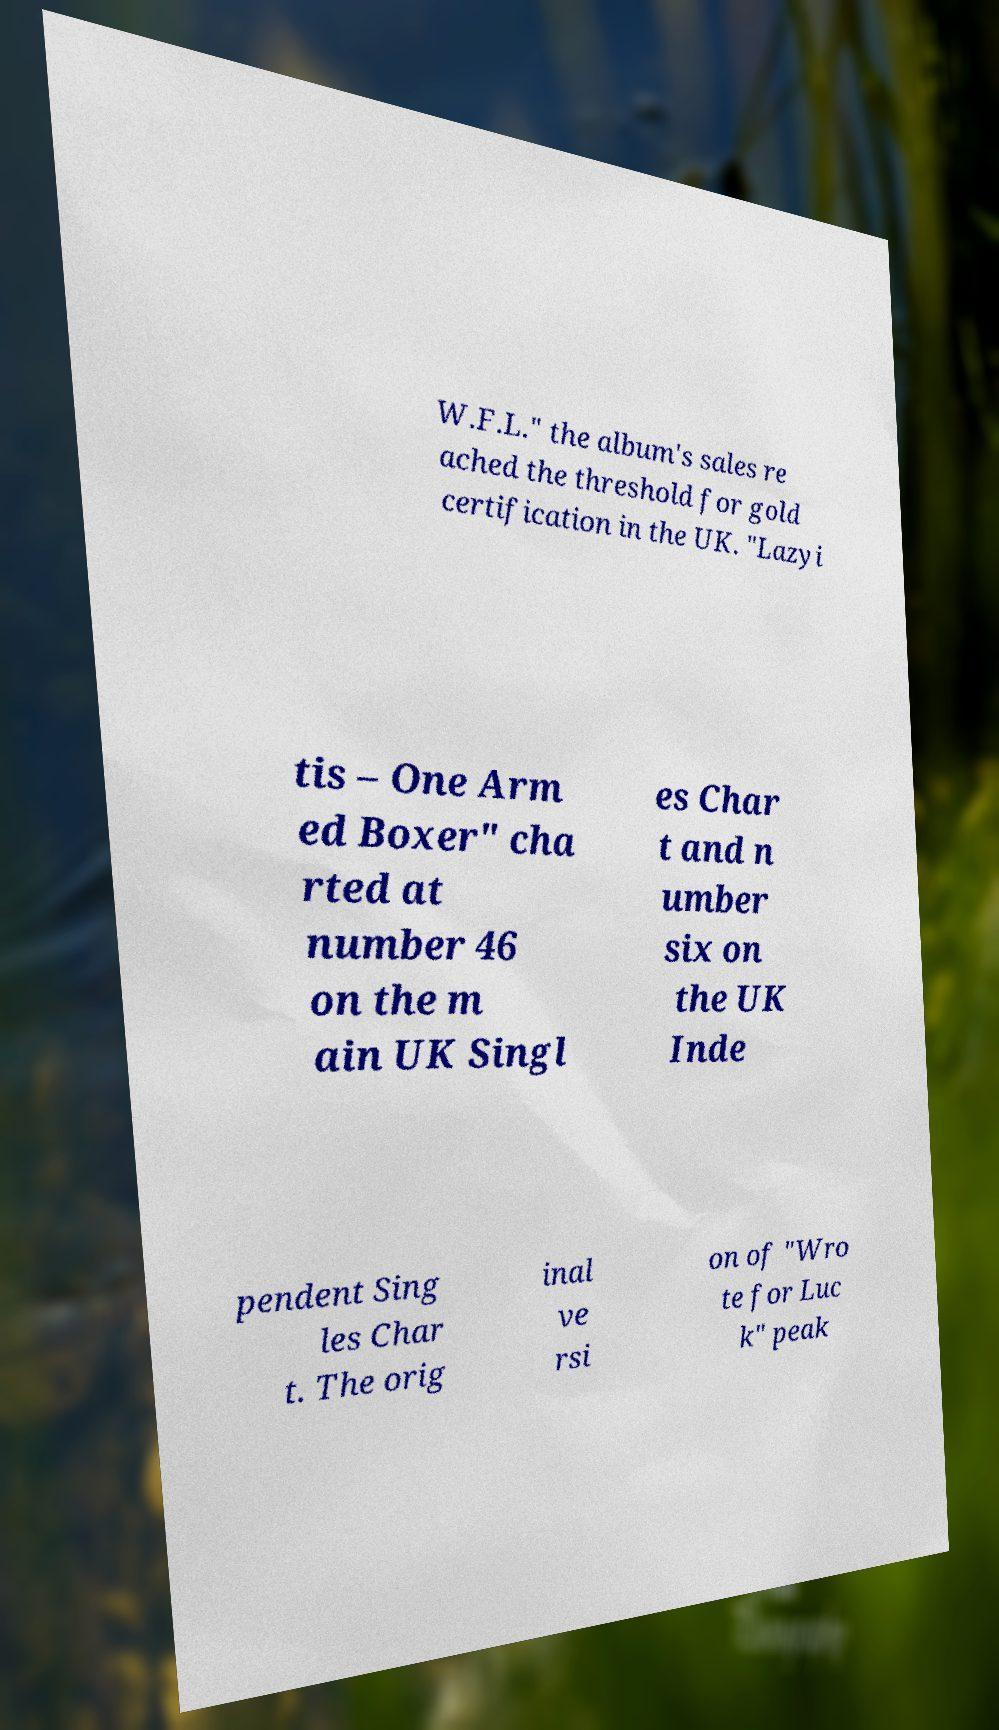Can you read and provide the text displayed in the image?This photo seems to have some interesting text. Can you extract and type it out for me? W.F.L." the album's sales re ached the threshold for gold certification in the UK. "Lazyi tis – One Arm ed Boxer" cha rted at number 46 on the m ain UK Singl es Char t and n umber six on the UK Inde pendent Sing les Char t. The orig inal ve rsi on of "Wro te for Luc k" peak 